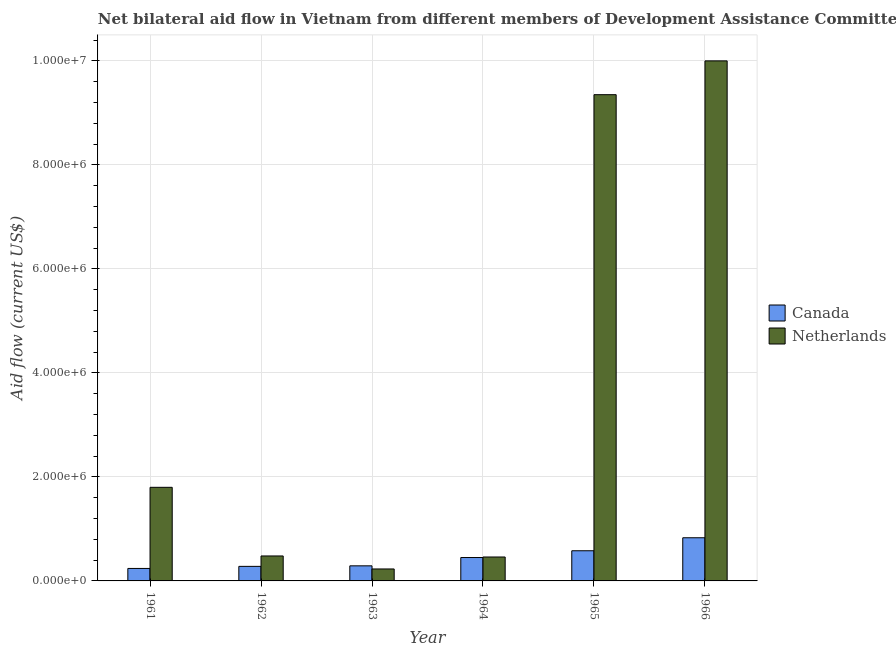How many different coloured bars are there?
Your answer should be compact. 2. Are the number of bars on each tick of the X-axis equal?
Make the answer very short. Yes. How many bars are there on the 6th tick from the left?
Offer a terse response. 2. How many bars are there on the 1st tick from the right?
Keep it short and to the point. 2. What is the label of the 6th group of bars from the left?
Keep it short and to the point. 1966. In how many cases, is the number of bars for a given year not equal to the number of legend labels?
Your answer should be very brief. 0. What is the amount of aid given by netherlands in 1961?
Give a very brief answer. 1.80e+06. Across all years, what is the maximum amount of aid given by netherlands?
Make the answer very short. 1.00e+07. Across all years, what is the minimum amount of aid given by canada?
Keep it short and to the point. 2.40e+05. In which year was the amount of aid given by canada maximum?
Make the answer very short. 1966. In which year was the amount of aid given by netherlands minimum?
Your response must be concise. 1963. What is the total amount of aid given by canada in the graph?
Offer a very short reply. 2.67e+06. What is the difference between the amount of aid given by canada in 1962 and that in 1965?
Your answer should be compact. -3.00e+05. What is the difference between the amount of aid given by netherlands in 1962 and the amount of aid given by canada in 1963?
Your answer should be very brief. 2.50e+05. What is the average amount of aid given by netherlands per year?
Give a very brief answer. 3.72e+06. In the year 1961, what is the difference between the amount of aid given by netherlands and amount of aid given by canada?
Offer a terse response. 0. In how many years, is the amount of aid given by netherlands greater than 10000000 US$?
Offer a terse response. 0. What is the difference between the highest and the second highest amount of aid given by netherlands?
Offer a terse response. 6.50e+05. What is the difference between the highest and the lowest amount of aid given by netherlands?
Keep it short and to the point. 9.77e+06. What does the 2nd bar from the left in 1965 represents?
Offer a very short reply. Netherlands. What does the 1st bar from the right in 1962 represents?
Offer a very short reply. Netherlands. How many bars are there?
Offer a terse response. 12. What is the difference between two consecutive major ticks on the Y-axis?
Offer a very short reply. 2.00e+06. How are the legend labels stacked?
Provide a succinct answer. Vertical. What is the title of the graph?
Your response must be concise. Net bilateral aid flow in Vietnam from different members of Development Assistance Committee. Does "Register a business" appear as one of the legend labels in the graph?
Offer a very short reply. No. What is the label or title of the X-axis?
Keep it short and to the point. Year. What is the Aid flow (current US$) in Canada in 1961?
Ensure brevity in your answer.  2.40e+05. What is the Aid flow (current US$) of Netherlands in 1961?
Your answer should be compact. 1.80e+06. What is the Aid flow (current US$) of Netherlands in 1963?
Give a very brief answer. 2.30e+05. What is the Aid flow (current US$) in Canada in 1964?
Offer a very short reply. 4.50e+05. What is the Aid flow (current US$) in Canada in 1965?
Keep it short and to the point. 5.80e+05. What is the Aid flow (current US$) in Netherlands in 1965?
Your answer should be very brief. 9.35e+06. What is the Aid flow (current US$) in Canada in 1966?
Keep it short and to the point. 8.30e+05. What is the Aid flow (current US$) in Netherlands in 1966?
Offer a terse response. 1.00e+07. Across all years, what is the maximum Aid flow (current US$) of Canada?
Offer a very short reply. 8.30e+05. Across all years, what is the maximum Aid flow (current US$) in Netherlands?
Provide a short and direct response. 1.00e+07. Across all years, what is the minimum Aid flow (current US$) of Canada?
Keep it short and to the point. 2.40e+05. Across all years, what is the minimum Aid flow (current US$) in Netherlands?
Your answer should be very brief. 2.30e+05. What is the total Aid flow (current US$) of Canada in the graph?
Offer a very short reply. 2.67e+06. What is the total Aid flow (current US$) of Netherlands in the graph?
Keep it short and to the point. 2.23e+07. What is the difference between the Aid flow (current US$) in Canada in 1961 and that in 1962?
Make the answer very short. -4.00e+04. What is the difference between the Aid flow (current US$) in Netherlands in 1961 and that in 1962?
Your response must be concise. 1.32e+06. What is the difference between the Aid flow (current US$) in Canada in 1961 and that in 1963?
Give a very brief answer. -5.00e+04. What is the difference between the Aid flow (current US$) in Netherlands in 1961 and that in 1963?
Keep it short and to the point. 1.57e+06. What is the difference between the Aid flow (current US$) of Netherlands in 1961 and that in 1964?
Ensure brevity in your answer.  1.34e+06. What is the difference between the Aid flow (current US$) in Canada in 1961 and that in 1965?
Provide a short and direct response. -3.40e+05. What is the difference between the Aid flow (current US$) of Netherlands in 1961 and that in 1965?
Your answer should be compact. -7.55e+06. What is the difference between the Aid flow (current US$) of Canada in 1961 and that in 1966?
Make the answer very short. -5.90e+05. What is the difference between the Aid flow (current US$) in Netherlands in 1961 and that in 1966?
Your answer should be very brief. -8.20e+06. What is the difference between the Aid flow (current US$) of Netherlands in 1962 and that in 1964?
Offer a terse response. 2.00e+04. What is the difference between the Aid flow (current US$) of Netherlands in 1962 and that in 1965?
Offer a very short reply. -8.87e+06. What is the difference between the Aid flow (current US$) of Canada in 1962 and that in 1966?
Offer a very short reply. -5.50e+05. What is the difference between the Aid flow (current US$) in Netherlands in 1962 and that in 1966?
Your answer should be very brief. -9.52e+06. What is the difference between the Aid flow (current US$) in Canada in 1963 and that in 1964?
Offer a very short reply. -1.60e+05. What is the difference between the Aid flow (current US$) of Netherlands in 1963 and that in 1965?
Provide a succinct answer. -9.12e+06. What is the difference between the Aid flow (current US$) in Canada in 1963 and that in 1966?
Offer a terse response. -5.40e+05. What is the difference between the Aid flow (current US$) of Netherlands in 1963 and that in 1966?
Your answer should be compact. -9.77e+06. What is the difference between the Aid flow (current US$) in Canada in 1964 and that in 1965?
Give a very brief answer. -1.30e+05. What is the difference between the Aid flow (current US$) of Netherlands in 1964 and that in 1965?
Make the answer very short. -8.89e+06. What is the difference between the Aid flow (current US$) of Canada in 1964 and that in 1966?
Your answer should be very brief. -3.80e+05. What is the difference between the Aid flow (current US$) in Netherlands in 1964 and that in 1966?
Give a very brief answer. -9.54e+06. What is the difference between the Aid flow (current US$) in Canada in 1965 and that in 1966?
Your answer should be compact. -2.50e+05. What is the difference between the Aid flow (current US$) in Netherlands in 1965 and that in 1966?
Offer a very short reply. -6.50e+05. What is the difference between the Aid flow (current US$) of Canada in 1961 and the Aid flow (current US$) of Netherlands in 1965?
Make the answer very short. -9.11e+06. What is the difference between the Aid flow (current US$) in Canada in 1961 and the Aid flow (current US$) in Netherlands in 1966?
Your answer should be very brief. -9.76e+06. What is the difference between the Aid flow (current US$) of Canada in 1962 and the Aid flow (current US$) of Netherlands in 1964?
Offer a terse response. -1.80e+05. What is the difference between the Aid flow (current US$) of Canada in 1962 and the Aid flow (current US$) of Netherlands in 1965?
Give a very brief answer. -9.07e+06. What is the difference between the Aid flow (current US$) in Canada in 1962 and the Aid flow (current US$) in Netherlands in 1966?
Keep it short and to the point. -9.72e+06. What is the difference between the Aid flow (current US$) of Canada in 1963 and the Aid flow (current US$) of Netherlands in 1964?
Keep it short and to the point. -1.70e+05. What is the difference between the Aid flow (current US$) of Canada in 1963 and the Aid flow (current US$) of Netherlands in 1965?
Offer a terse response. -9.06e+06. What is the difference between the Aid flow (current US$) of Canada in 1963 and the Aid flow (current US$) of Netherlands in 1966?
Give a very brief answer. -9.71e+06. What is the difference between the Aid flow (current US$) of Canada in 1964 and the Aid flow (current US$) of Netherlands in 1965?
Your answer should be very brief. -8.90e+06. What is the difference between the Aid flow (current US$) in Canada in 1964 and the Aid flow (current US$) in Netherlands in 1966?
Your answer should be very brief. -9.55e+06. What is the difference between the Aid flow (current US$) in Canada in 1965 and the Aid flow (current US$) in Netherlands in 1966?
Provide a short and direct response. -9.42e+06. What is the average Aid flow (current US$) of Canada per year?
Your answer should be compact. 4.45e+05. What is the average Aid flow (current US$) in Netherlands per year?
Offer a terse response. 3.72e+06. In the year 1961, what is the difference between the Aid flow (current US$) of Canada and Aid flow (current US$) of Netherlands?
Your answer should be compact. -1.56e+06. In the year 1962, what is the difference between the Aid flow (current US$) of Canada and Aid flow (current US$) of Netherlands?
Your answer should be compact. -2.00e+05. In the year 1963, what is the difference between the Aid flow (current US$) in Canada and Aid flow (current US$) in Netherlands?
Offer a very short reply. 6.00e+04. In the year 1964, what is the difference between the Aid flow (current US$) in Canada and Aid flow (current US$) in Netherlands?
Offer a terse response. -10000. In the year 1965, what is the difference between the Aid flow (current US$) in Canada and Aid flow (current US$) in Netherlands?
Your answer should be compact. -8.77e+06. In the year 1966, what is the difference between the Aid flow (current US$) of Canada and Aid flow (current US$) of Netherlands?
Provide a short and direct response. -9.17e+06. What is the ratio of the Aid flow (current US$) in Canada in 1961 to that in 1962?
Your response must be concise. 0.86. What is the ratio of the Aid flow (current US$) of Netherlands in 1961 to that in 1962?
Your answer should be compact. 3.75. What is the ratio of the Aid flow (current US$) in Canada in 1961 to that in 1963?
Make the answer very short. 0.83. What is the ratio of the Aid flow (current US$) of Netherlands in 1961 to that in 1963?
Your answer should be compact. 7.83. What is the ratio of the Aid flow (current US$) of Canada in 1961 to that in 1964?
Your answer should be compact. 0.53. What is the ratio of the Aid flow (current US$) in Netherlands in 1961 to that in 1964?
Offer a terse response. 3.91. What is the ratio of the Aid flow (current US$) in Canada in 1961 to that in 1965?
Make the answer very short. 0.41. What is the ratio of the Aid flow (current US$) in Netherlands in 1961 to that in 1965?
Offer a terse response. 0.19. What is the ratio of the Aid flow (current US$) of Canada in 1961 to that in 1966?
Your response must be concise. 0.29. What is the ratio of the Aid flow (current US$) of Netherlands in 1961 to that in 1966?
Provide a succinct answer. 0.18. What is the ratio of the Aid flow (current US$) of Canada in 1962 to that in 1963?
Ensure brevity in your answer.  0.97. What is the ratio of the Aid flow (current US$) in Netherlands in 1962 to that in 1963?
Your answer should be compact. 2.09. What is the ratio of the Aid flow (current US$) in Canada in 1962 to that in 1964?
Offer a very short reply. 0.62. What is the ratio of the Aid flow (current US$) in Netherlands in 1962 to that in 1964?
Your answer should be compact. 1.04. What is the ratio of the Aid flow (current US$) of Canada in 1962 to that in 1965?
Offer a very short reply. 0.48. What is the ratio of the Aid flow (current US$) in Netherlands in 1962 to that in 1965?
Offer a terse response. 0.05. What is the ratio of the Aid flow (current US$) in Canada in 1962 to that in 1966?
Provide a short and direct response. 0.34. What is the ratio of the Aid flow (current US$) of Netherlands in 1962 to that in 1966?
Your response must be concise. 0.05. What is the ratio of the Aid flow (current US$) of Canada in 1963 to that in 1964?
Your answer should be compact. 0.64. What is the ratio of the Aid flow (current US$) in Netherlands in 1963 to that in 1964?
Keep it short and to the point. 0.5. What is the ratio of the Aid flow (current US$) of Canada in 1963 to that in 1965?
Your response must be concise. 0.5. What is the ratio of the Aid flow (current US$) in Netherlands in 1963 to that in 1965?
Keep it short and to the point. 0.02. What is the ratio of the Aid flow (current US$) of Canada in 1963 to that in 1966?
Offer a terse response. 0.35. What is the ratio of the Aid flow (current US$) of Netherlands in 1963 to that in 1966?
Your answer should be very brief. 0.02. What is the ratio of the Aid flow (current US$) in Canada in 1964 to that in 1965?
Offer a very short reply. 0.78. What is the ratio of the Aid flow (current US$) of Netherlands in 1964 to that in 1965?
Provide a short and direct response. 0.05. What is the ratio of the Aid flow (current US$) of Canada in 1964 to that in 1966?
Offer a very short reply. 0.54. What is the ratio of the Aid flow (current US$) of Netherlands in 1964 to that in 1966?
Ensure brevity in your answer.  0.05. What is the ratio of the Aid flow (current US$) of Canada in 1965 to that in 1966?
Offer a very short reply. 0.7. What is the ratio of the Aid flow (current US$) in Netherlands in 1965 to that in 1966?
Keep it short and to the point. 0.94. What is the difference between the highest and the second highest Aid flow (current US$) of Canada?
Your response must be concise. 2.50e+05. What is the difference between the highest and the second highest Aid flow (current US$) in Netherlands?
Ensure brevity in your answer.  6.50e+05. What is the difference between the highest and the lowest Aid flow (current US$) in Canada?
Give a very brief answer. 5.90e+05. What is the difference between the highest and the lowest Aid flow (current US$) of Netherlands?
Keep it short and to the point. 9.77e+06. 